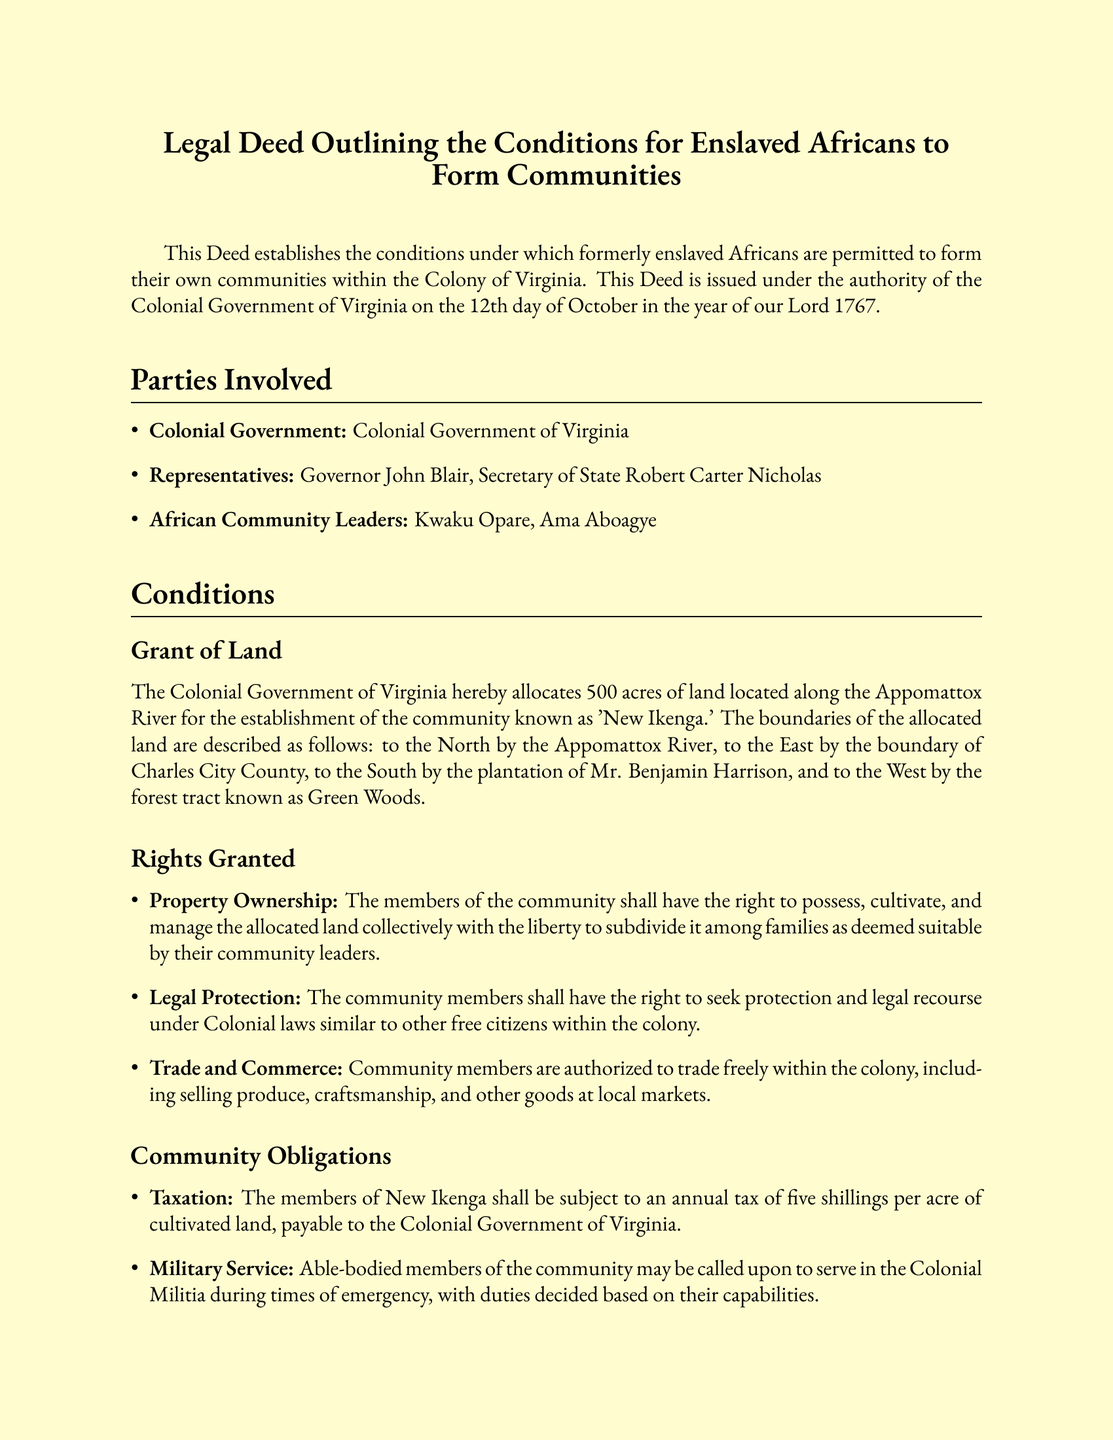What is the title of the document? The title of the document is presented at the beginning, indicating its purpose and content.
Answer: Legal Deed Outlining the Conditions for Enslaved Africans to Form Communities Who are the African Community Leaders mentioned in the document? The document lists the names of the leaders representing the African community, which are explicitly mentioned.
Answer: Kwaku Opare, Ama Aboagye How many acres of land are allocated for the community? The document specifies the amount of land granted to the community for their establishment.
Answer: 500 acres What annual tax must the members of New Ikenga pay per acre? The taxation details are provided in the obligations section, specifying the amount per acre.
Answer: Five shillings What river is the northern boundary of the allocated land? The document provides geographical details about the boundaries of the land, including the river.
Answer: Appomattox River Who signed on behalf of the Colonial Government? The document indicates the representatives of the Colonial Government who signed the Deed, which is a crucial part of its authenticity.
Answer: Governor John Blair, Secretary Robert Carter Nicholas What form of governance is established for the community? The document outlines how leadership and governance will be structured within the African community.
Answer: Council of elders What is one of the community's obligations related to military service? The document mentions the obligation of able-bodied members related to military service, which indicates their responsibilities.
Answer: Serve in the Colonial Militia What legal protections are granted to the community members? The rights listed provide insight into the legal protections afforded to the community members under Colonial laws.
Answer: Seek protection and legal recourse under Colonial laws 